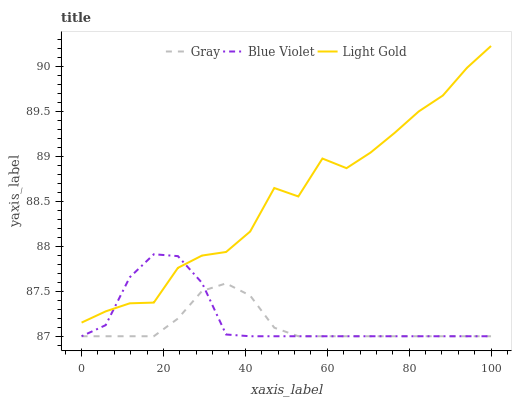Does Gray have the minimum area under the curve?
Answer yes or no. Yes. Does Light Gold have the maximum area under the curve?
Answer yes or no. Yes. Does Blue Violet have the minimum area under the curve?
Answer yes or no. No. Does Blue Violet have the maximum area under the curve?
Answer yes or no. No. Is Gray the smoothest?
Answer yes or no. Yes. Is Light Gold the roughest?
Answer yes or no. Yes. Is Blue Violet the smoothest?
Answer yes or no. No. Is Blue Violet the roughest?
Answer yes or no. No. Does Light Gold have the lowest value?
Answer yes or no. No. Does Blue Violet have the highest value?
Answer yes or no. No. Is Gray less than Light Gold?
Answer yes or no. Yes. Is Light Gold greater than Gray?
Answer yes or no. Yes. Does Gray intersect Light Gold?
Answer yes or no. No. 